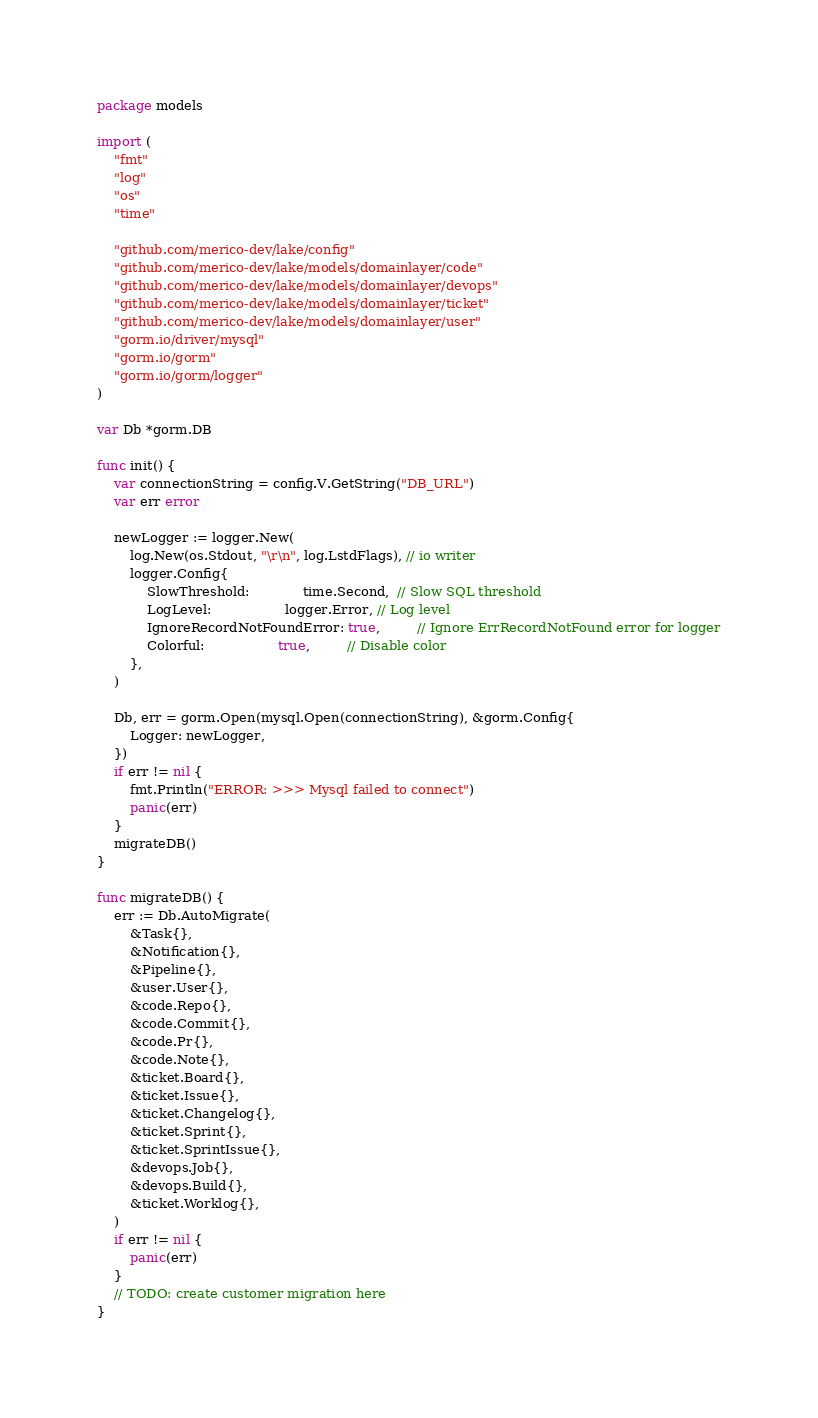Convert code to text. <code><loc_0><loc_0><loc_500><loc_500><_Go_>package models

import (
	"fmt"
	"log"
	"os"
	"time"

	"github.com/merico-dev/lake/config"
	"github.com/merico-dev/lake/models/domainlayer/code"
	"github.com/merico-dev/lake/models/domainlayer/devops"
	"github.com/merico-dev/lake/models/domainlayer/ticket"
	"github.com/merico-dev/lake/models/domainlayer/user"
	"gorm.io/driver/mysql"
	"gorm.io/gorm"
	"gorm.io/gorm/logger"
)

var Db *gorm.DB

func init() {
	var connectionString = config.V.GetString("DB_URL")
	var err error

	newLogger := logger.New(
		log.New(os.Stdout, "\r\n", log.LstdFlags), // io writer
		logger.Config{
			SlowThreshold:             time.Second,  // Slow SQL threshold
			LogLevel:                  logger.Error, // Log level
			IgnoreRecordNotFoundError: true,         // Ignore ErrRecordNotFound error for logger
			Colorful:                  true,         // Disable color
		},
	)

	Db, err = gorm.Open(mysql.Open(connectionString), &gorm.Config{
		Logger: newLogger,
	})
	if err != nil {
		fmt.Println("ERROR: >>> Mysql failed to connect")
		panic(err)
	}
	migrateDB()
}

func migrateDB() {
	err := Db.AutoMigrate(
		&Task{},
		&Notification{},
		&Pipeline{},
		&user.User{},
		&code.Repo{},
		&code.Commit{},
		&code.Pr{},
		&code.Note{},
		&ticket.Board{},
		&ticket.Issue{},
		&ticket.Changelog{},
		&ticket.Sprint{},
		&ticket.SprintIssue{},
		&devops.Job{},
		&devops.Build{},
		&ticket.Worklog{},
	)
	if err != nil {
		panic(err)
	}
	// TODO: create customer migration here
}
</code> 